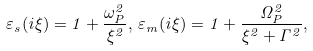Convert formula to latex. <formula><loc_0><loc_0><loc_500><loc_500>\varepsilon _ { s } ( i \xi ) = 1 + \frac { \omega ^ { 2 } _ { P } } { \xi ^ { 2 } } , \, \varepsilon _ { m } ( i \xi ) = 1 + \frac { \Omega ^ { 2 } _ { P } } { \xi ^ { 2 } + \Gamma ^ { 2 } } ,</formula> 